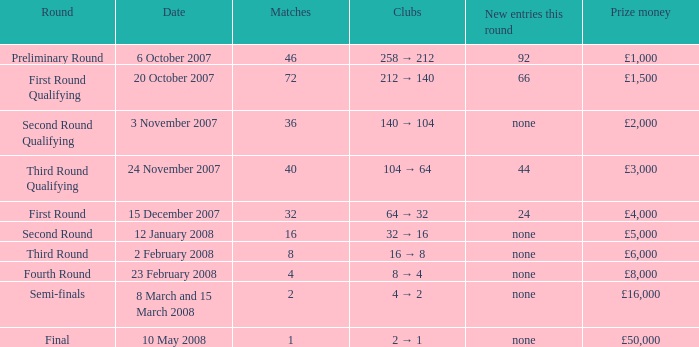How many new entries this round have clubs 2 → 1? None. 